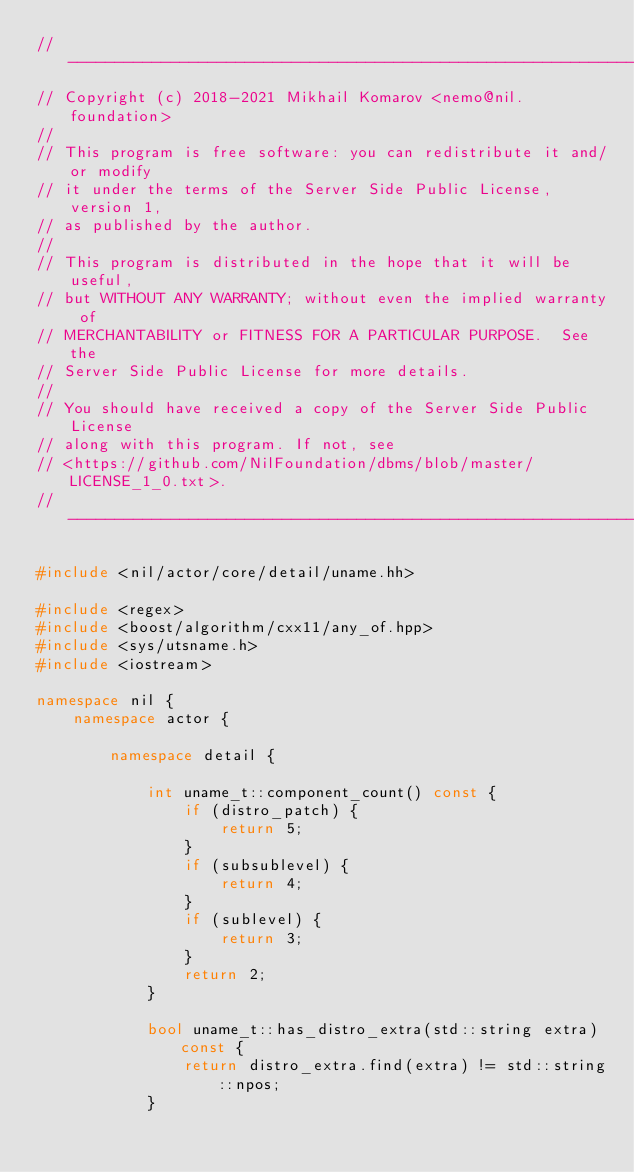<code> <loc_0><loc_0><loc_500><loc_500><_C++_>//---------------------------------------------------------------------------//
// Copyright (c) 2018-2021 Mikhail Komarov <nemo@nil.foundation>
//
// This program is free software: you can redistribute it and/or modify
// it under the terms of the Server Side Public License, version 1,
// as published by the author.
//
// This program is distributed in the hope that it will be useful,
// but WITHOUT ANY WARRANTY; without even the implied warranty of
// MERCHANTABILITY or FITNESS FOR A PARTICULAR PURPOSE.  See the
// Server Side Public License for more details.
//
// You should have received a copy of the Server Side Public License
// along with this program. If not, see
// <https://github.com/NilFoundation/dbms/blob/master/LICENSE_1_0.txt>.
//---------------------------------------------------------------------------//

#include <nil/actor/core/detail/uname.hh>

#include <regex>
#include <boost/algorithm/cxx11/any_of.hpp>
#include <sys/utsname.h>
#include <iostream>

namespace nil {
    namespace actor {

        namespace detail {

            int uname_t::component_count() const {
                if (distro_patch) {
                    return 5;
                }
                if (subsublevel) {
                    return 4;
                }
                if (sublevel) {
                    return 3;
                }
                return 2;
            }

            bool uname_t::has_distro_extra(std::string extra) const {
                return distro_extra.find(extra) != std::string::npos;
            }
</code> 